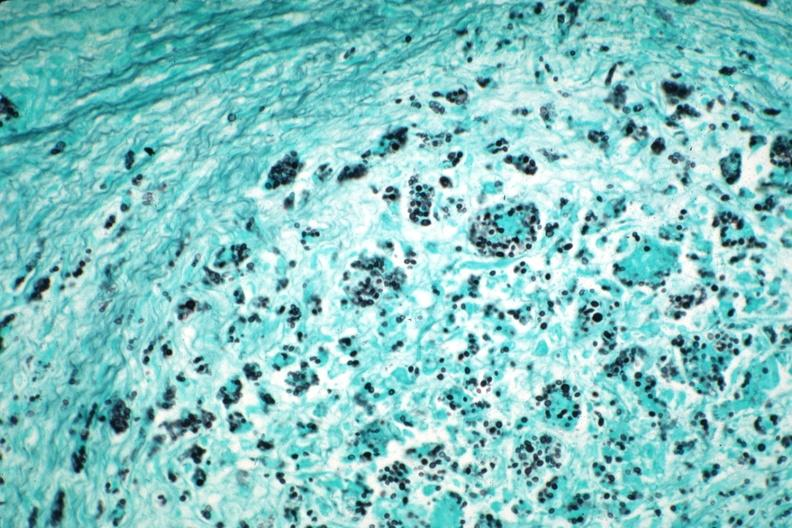what does this image show?
Answer the question using a single word or phrase. Gms illustrates organisms granulomatous prostatitis case of aids 